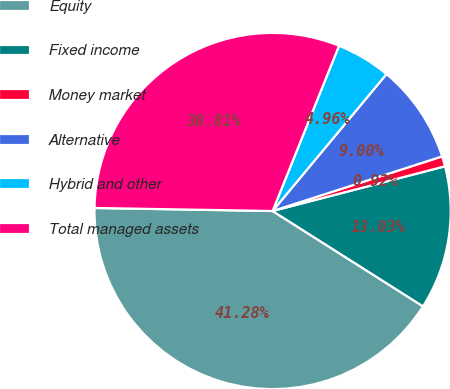<chart> <loc_0><loc_0><loc_500><loc_500><pie_chart><fcel>Equity<fcel>Fixed income<fcel>Money market<fcel>Alternative<fcel>Hybrid and other<fcel>Total managed assets<nl><fcel>41.28%<fcel>13.03%<fcel>0.92%<fcel>9.0%<fcel>4.96%<fcel>30.81%<nl></chart> 